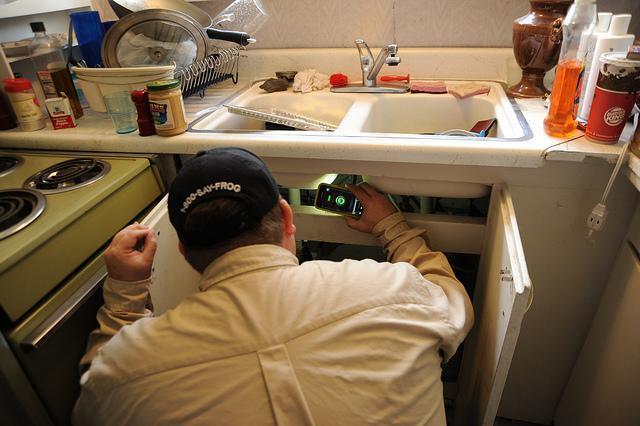How many sinks are there?
Give a very brief answer. 2. How many bottles are in the picture?
Give a very brief answer. 2. How many laptops are there?
Give a very brief answer. 0. 